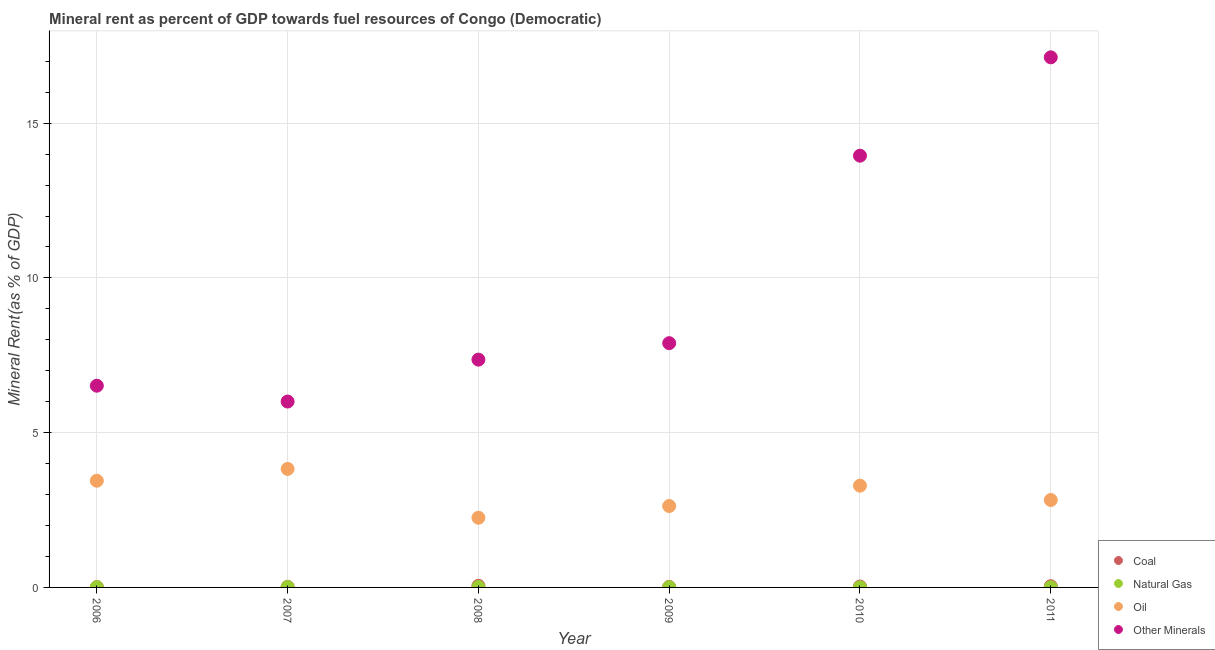How many different coloured dotlines are there?
Give a very brief answer. 4. Is the number of dotlines equal to the number of legend labels?
Keep it short and to the point. Yes. What is the oil rent in 2009?
Your answer should be compact. 2.63. Across all years, what is the maximum  rent of other minerals?
Make the answer very short. 17.13. Across all years, what is the minimum  rent of other minerals?
Provide a short and direct response. 6.01. In which year was the  rent of other minerals maximum?
Provide a succinct answer. 2011. In which year was the oil rent minimum?
Your answer should be compact. 2008. What is the total oil rent in the graph?
Provide a succinct answer. 18.27. What is the difference between the coal rent in 2006 and that in 2007?
Keep it short and to the point. -0.01. What is the difference between the  rent of other minerals in 2011 and the natural gas rent in 2007?
Give a very brief answer. 17.11. What is the average oil rent per year?
Provide a short and direct response. 3.05. In the year 2010, what is the difference between the oil rent and  rent of other minerals?
Ensure brevity in your answer.  -10.66. In how many years, is the natural gas rent greater than 7 %?
Provide a succinct answer. 0. What is the ratio of the natural gas rent in 2006 to that in 2010?
Provide a succinct answer. 1.09. What is the difference between the highest and the second highest coal rent?
Provide a succinct answer. 0.01. What is the difference between the highest and the lowest  rent of other minerals?
Ensure brevity in your answer.  11.12. In how many years, is the oil rent greater than the average oil rent taken over all years?
Offer a very short reply. 3. Is the sum of the natural gas rent in 2007 and 2009 greater than the maximum oil rent across all years?
Your answer should be compact. No. Is it the case that in every year, the sum of the coal rent and natural gas rent is greater than the oil rent?
Ensure brevity in your answer.  No. Is the oil rent strictly less than the  rent of other minerals over the years?
Ensure brevity in your answer.  Yes. How many dotlines are there?
Your answer should be very brief. 4. Are the values on the major ticks of Y-axis written in scientific E-notation?
Your response must be concise. No. Where does the legend appear in the graph?
Offer a very short reply. Bottom right. How are the legend labels stacked?
Make the answer very short. Vertical. What is the title of the graph?
Keep it short and to the point. Mineral rent as percent of GDP towards fuel resources of Congo (Democratic). What is the label or title of the Y-axis?
Ensure brevity in your answer.  Mineral Rent(as % of GDP). What is the Mineral Rent(as % of GDP) in Coal in 2006?
Provide a succinct answer. 0.01. What is the Mineral Rent(as % of GDP) of Natural Gas in 2006?
Provide a succinct answer. 0.01. What is the Mineral Rent(as % of GDP) of Oil in 2006?
Your response must be concise. 3.45. What is the Mineral Rent(as % of GDP) of Other Minerals in 2006?
Keep it short and to the point. 6.52. What is the Mineral Rent(as % of GDP) of Coal in 2007?
Give a very brief answer. 0.02. What is the Mineral Rent(as % of GDP) of Natural Gas in 2007?
Ensure brevity in your answer.  0.01. What is the Mineral Rent(as % of GDP) of Oil in 2007?
Your answer should be very brief. 3.83. What is the Mineral Rent(as % of GDP) of Other Minerals in 2007?
Keep it short and to the point. 6.01. What is the Mineral Rent(as % of GDP) of Coal in 2008?
Your response must be concise. 0.05. What is the Mineral Rent(as % of GDP) in Natural Gas in 2008?
Keep it short and to the point. 0.02. What is the Mineral Rent(as % of GDP) in Oil in 2008?
Your response must be concise. 2.25. What is the Mineral Rent(as % of GDP) in Other Minerals in 2008?
Make the answer very short. 7.36. What is the Mineral Rent(as % of GDP) of Coal in 2009?
Keep it short and to the point. 0.02. What is the Mineral Rent(as % of GDP) in Natural Gas in 2009?
Your answer should be compact. 0.01. What is the Mineral Rent(as % of GDP) of Oil in 2009?
Your answer should be very brief. 2.63. What is the Mineral Rent(as % of GDP) in Other Minerals in 2009?
Offer a terse response. 7.89. What is the Mineral Rent(as % of GDP) in Coal in 2010?
Your answer should be very brief. 0.03. What is the Mineral Rent(as % of GDP) of Natural Gas in 2010?
Provide a succinct answer. 0.01. What is the Mineral Rent(as % of GDP) in Oil in 2010?
Provide a succinct answer. 3.29. What is the Mineral Rent(as % of GDP) of Other Minerals in 2010?
Keep it short and to the point. 13.95. What is the Mineral Rent(as % of GDP) in Coal in 2011?
Provide a short and direct response. 0.04. What is the Mineral Rent(as % of GDP) of Natural Gas in 2011?
Your response must be concise. 0.01. What is the Mineral Rent(as % of GDP) of Oil in 2011?
Ensure brevity in your answer.  2.82. What is the Mineral Rent(as % of GDP) of Other Minerals in 2011?
Your answer should be very brief. 17.13. Across all years, what is the maximum Mineral Rent(as % of GDP) of Coal?
Offer a terse response. 0.05. Across all years, what is the maximum Mineral Rent(as % of GDP) in Natural Gas?
Your answer should be compact. 0.02. Across all years, what is the maximum Mineral Rent(as % of GDP) of Oil?
Give a very brief answer. 3.83. Across all years, what is the maximum Mineral Rent(as % of GDP) in Other Minerals?
Give a very brief answer. 17.13. Across all years, what is the minimum Mineral Rent(as % of GDP) of Coal?
Make the answer very short. 0.01. Across all years, what is the minimum Mineral Rent(as % of GDP) of Natural Gas?
Offer a terse response. 0.01. Across all years, what is the minimum Mineral Rent(as % of GDP) in Oil?
Your response must be concise. 2.25. Across all years, what is the minimum Mineral Rent(as % of GDP) of Other Minerals?
Make the answer very short. 6.01. What is the total Mineral Rent(as % of GDP) in Coal in the graph?
Provide a short and direct response. 0.17. What is the total Mineral Rent(as % of GDP) of Natural Gas in the graph?
Offer a very short reply. 0.05. What is the total Mineral Rent(as % of GDP) of Oil in the graph?
Provide a succinct answer. 18.27. What is the total Mineral Rent(as % of GDP) of Other Minerals in the graph?
Your response must be concise. 58.85. What is the difference between the Mineral Rent(as % of GDP) in Coal in 2006 and that in 2007?
Keep it short and to the point. -0.01. What is the difference between the Mineral Rent(as % of GDP) in Natural Gas in 2006 and that in 2007?
Give a very brief answer. -0.01. What is the difference between the Mineral Rent(as % of GDP) in Oil in 2006 and that in 2007?
Your answer should be very brief. -0.38. What is the difference between the Mineral Rent(as % of GDP) of Other Minerals in 2006 and that in 2007?
Provide a short and direct response. 0.51. What is the difference between the Mineral Rent(as % of GDP) in Coal in 2006 and that in 2008?
Your answer should be very brief. -0.04. What is the difference between the Mineral Rent(as % of GDP) in Natural Gas in 2006 and that in 2008?
Provide a short and direct response. -0.01. What is the difference between the Mineral Rent(as % of GDP) in Oil in 2006 and that in 2008?
Your answer should be compact. 1.2. What is the difference between the Mineral Rent(as % of GDP) in Other Minerals in 2006 and that in 2008?
Offer a very short reply. -0.84. What is the difference between the Mineral Rent(as % of GDP) in Coal in 2006 and that in 2009?
Make the answer very short. -0.01. What is the difference between the Mineral Rent(as % of GDP) of Natural Gas in 2006 and that in 2009?
Your response must be concise. -0. What is the difference between the Mineral Rent(as % of GDP) of Oil in 2006 and that in 2009?
Provide a short and direct response. 0.82. What is the difference between the Mineral Rent(as % of GDP) in Other Minerals in 2006 and that in 2009?
Make the answer very short. -1.37. What is the difference between the Mineral Rent(as % of GDP) in Coal in 2006 and that in 2010?
Your answer should be very brief. -0.02. What is the difference between the Mineral Rent(as % of GDP) of Natural Gas in 2006 and that in 2010?
Ensure brevity in your answer.  0. What is the difference between the Mineral Rent(as % of GDP) in Oil in 2006 and that in 2010?
Your answer should be very brief. 0.16. What is the difference between the Mineral Rent(as % of GDP) in Other Minerals in 2006 and that in 2010?
Give a very brief answer. -7.43. What is the difference between the Mineral Rent(as % of GDP) of Coal in 2006 and that in 2011?
Ensure brevity in your answer.  -0.03. What is the difference between the Mineral Rent(as % of GDP) of Natural Gas in 2006 and that in 2011?
Provide a short and direct response. 0. What is the difference between the Mineral Rent(as % of GDP) in Oil in 2006 and that in 2011?
Give a very brief answer. 0.62. What is the difference between the Mineral Rent(as % of GDP) in Other Minerals in 2006 and that in 2011?
Your answer should be compact. -10.61. What is the difference between the Mineral Rent(as % of GDP) of Coal in 2007 and that in 2008?
Keep it short and to the point. -0.03. What is the difference between the Mineral Rent(as % of GDP) of Natural Gas in 2007 and that in 2008?
Your answer should be very brief. -0. What is the difference between the Mineral Rent(as % of GDP) in Oil in 2007 and that in 2008?
Make the answer very short. 1.58. What is the difference between the Mineral Rent(as % of GDP) of Other Minerals in 2007 and that in 2008?
Provide a succinct answer. -1.35. What is the difference between the Mineral Rent(as % of GDP) of Natural Gas in 2007 and that in 2009?
Offer a very short reply. 0. What is the difference between the Mineral Rent(as % of GDP) of Oil in 2007 and that in 2009?
Keep it short and to the point. 1.2. What is the difference between the Mineral Rent(as % of GDP) in Other Minerals in 2007 and that in 2009?
Offer a terse response. -1.89. What is the difference between the Mineral Rent(as % of GDP) of Coal in 2007 and that in 2010?
Your answer should be compact. -0.01. What is the difference between the Mineral Rent(as % of GDP) of Natural Gas in 2007 and that in 2010?
Your answer should be compact. 0.01. What is the difference between the Mineral Rent(as % of GDP) in Oil in 2007 and that in 2010?
Offer a terse response. 0.54. What is the difference between the Mineral Rent(as % of GDP) of Other Minerals in 2007 and that in 2010?
Keep it short and to the point. -7.94. What is the difference between the Mineral Rent(as % of GDP) of Coal in 2007 and that in 2011?
Provide a short and direct response. -0.02. What is the difference between the Mineral Rent(as % of GDP) of Natural Gas in 2007 and that in 2011?
Your answer should be compact. 0.01. What is the difference between the Mineral Rent(as % of GDP) of Other Minerals in 2007 and that in 2011?
Provide a short and direct response. -11.12. What is the difference between the Mineral Rent(as % of GDP) in Coal in 2008 and that in 2009?
Your answer should be very brief. 0.04. What is the difference between the Mineral Rent(as % of GDP) of Natural Gas in 2008 and that in 2009?
Offer a very short reply. 0.01. What is the difference between the Mineral Rent(as % of GDP) of Oil in 2008 and that in 2009?
Provide a short and direct response. -0.38. What is the difference between the Mineral Rent(as % of GDP) of Other Minerals in 2008 and that in 2009?
Your response must be concise. -0.53. What is the difference between the Mineral Rent(as % of GDP) of Coal in 2008 and that in 2010?
Provide a succinct answer. 0.02. What is the difference between the Mineral Rent(as % of GDP) in Natural Gas in 2008 and that in 2010?
Provide a short and direct response. 0.01. What is the difference between the Mineral Rent(as % of GDP) in Oil in 2008 and that in 2010?
Offer a terse response. -1.04. What is the difference between the Mineral Rent(as % of GDP) in Other Minerals in 2008 and that in 2010?
Your response must be concise. -6.59. What is the difference between the Mineral Rent(as % of GDP) in Coal in 2008 and that in 2011?
Give a very brief answer. 0.01. What is the difference between the Mineral Rent(as % of GDP) of Natural Gas in 2008 and that in 2011?
Your answer should be compact. 0.01. What is the difference between the Mineral Rent(as % of GDP) in Oil in 2008 and that in 2011?
Your answer should be compact. -0.57. What is the difference between the Mineral Rent(as % of GDP) of Other Minerals in 2008 and that in 2011?
Your response must be concise. -9.77. What is the difference between the Mineral Rent(as % of GDP) of Coal in 2009 and that in 2010?
Make the answer very short. -0.01. What is the difference between the Mineral Rent(as % of GDP) in Natural Gas in 2009 and that in 2010?
Make the answer very short. 0. What is the difference between the Mineral Rent(as % of GDP) in Oil in 2009 and that in 2010?
Give a very brief answer. -0.66. What is the difference between the Mineral Rent(as % of GDP) of Other Minerals in 2009 and that in 2010?
Provide a short and direct response. -6.06. What is the difference between the Mineral Rent(as % of GDP) in Coal in 2009 and that in 2011?
Ensure brevity in your answer.  -0.02. What is the difference between the Mineral Rent(as % of GDP) in Natural Gas in 2009 and that in 2011?
Ensure brevity in your answer.  0. What is the difference between the Mineral Rent(as % of GDP) in Oil in 2009 and that in 2011?
Make the answer very short. -0.19. What is the difference between the Mineral Rent(as % of GDP) of Other Minerals in 2009 and that in 2011?
Offer a terse response. -9.24. What is the difference between the Mineral Rent(as % of GDP) in Coal in 2010 and that in 2011?
Your answer should be compact. -0.01. What is the difference between the Mineral Rent(as % of GDP) in Oil in 2010 and that in 2011?
Provide a succinct answer. 0.46. What is the difference between the Mineral Rent(as % of GDP) in Other Minerals in 2010 and that in 2011?
Your answer should be very brief. -3.18. What is the difference between the Mineral Rent(as % of GDP) of Coal in 2006 and the Mineral Rent(as % of GDP) of Natural Gas in 2007?
Your answer should be very brief. -0. What is the difference between the Mineral Rent(as % of GDP) of Coal in 2006 and the Mineral Rent(as % of GDP) of Oil in 2007?
Ensure brevity in your answer.  -3.82. What is the difference between the Mineral Rent(as % of GDP) in Coal in 2006 and the Mineral Rent(as % of GDP) in Other Minerals in 2007?
Give a very brief answer. -6. What is the difference between the Mineral Rent(as % of GDP) in Natural Gas in 2006 and the Mineral Rent(as % of GDP) in Oil in 2007?
Give a very brief answer. -3.82. What is the difference between the Mineral Rent(as % of GDP) of Natural Gas in 2006 and the Mineral Rent(as % of GDP) of Other Minerals in 2007?
Your answer should be compact. -6. What is the difference between the Mineral Rent(as % of GDP) of Oil in 2006 and the Mineral Rent(as % of GDP) of Other Minerals in 2007?
Provide a short and direct response. -2.56. What is the difference between the Mineral Rent(as % of GDP) of Coal in 2006 and the Mineral Rent(as % of GDP) of Natural Gas in 2008?
Ensure brevity in your answer.  -0.01. What is the difference between the Mineral Rent(as % of GDP) in Coal in 2006 and the Mineral Rent(as % of GDP) in Oil in 2008?
Offer a very short reply. -2.24. What is the difference between the Mineral Rent(as % of GDP) in Coal in 2006 and the Mineral Rent(as % of GDP) in Other Minerals in 2008?
Make the answer very short. -7.35. What is the difference between the Mineral Rent(as % of GDP) in Natural Gas in 2006 and the Mineral Rent(as % of GDP) in Oil in 2008?
Your response must be concise. -2.24. What is the difference between the Mineral Rent(as % of GDP) in Natural Gas in 2006 and the Mineral Rent(as % of GDP) in Other Minerals in 2008?
Your answer should be compact. -7.35. What is the difference between the Mineral Rent(as % of GDP) in Oil in 2006 and the Mineral Rent(as % of GDP) in Other Minerals in 2008?
Offer a terse response. -3.91. What is the difference between the Mineral Rent(as % of GDP) in Coal in 2006 and the Mineral Rent(as % of GDP) in Natural Gas in 2009?
Your answer should be compact. 0. What is the difference between the Mineral Rent(as % of GDP) of Coal in 2006 and the Mineral Rent(as % of GDP) of Oil in 2009?
Make the answer very short. -2.62. What is the difference between the Mineral Rent(as % of GDP) in Coal in 2006 and the Mineral Rent(as % of GDP) in Other Minerals in 2009?
Give a very brief answer. -7.88. What is the difference between the Mineral Rent(as % of GDP) in Natural Gas in 2006 and the Mineral Rent(as % of GDP) in Oil in 2009?
Your response must be concise. -2.62. What is the difference between the Mineral Rent(as % of GDP) of Natural Gas in 2006 and the Mineral Rent(as % of GDP) of Other Minerals in 2009?
Your response must be concise. -7.88. What is the difference between the Mineral Rent(as % of GDP) of Oil in 2006 and the Mineral Rent(as % of GDP) of Other Minerals in 2009?
Your answer should be compact. -4.44. What is the difference between the Mineral Rent(as % of GDP) in Coal in 2006 and the Mineral Rent(as % of GDP) in Natural Gas in 2010?
Keep it short and to the point. 0. What is the difference between the Mineral Rent(as % of GDP) in Coal in 2006 and the Mineral Rent(as % of GDP) in Oil in 2010?
Provide a succinct answer. -3.28. What is the difference between the Mineral Rent(as % of GDP) in Coal in 2006 and the Mineral Rent(as % of GDP) in Other Minerals in 2010?
Your response must be concise. -13.94. What is the difference between the Mineral Rent(as % of GDP) of Natural Gas in 2006 and the Mineral Rent(as % of GDP) of Oil in 2010?
Offer a terse response. -3.28. What is the difference between the Mineral Rent(as % of GDP) in Natural Gas in 2006 and the Mineral Rent(as % of GDP) in Other Minerals in 2010?
Your response must be concise. -13.94. What is the difference between the Mineral Rent(as % of GDP) of Oil in 2006 and the Mineral Rent(as % of GDP) of Other Minerals in 2010?
Your answer should be very brief. -10.5. What is the difference between the Mineral Rent(as % of GDP) of Coal in 2006 and the Mineral Rent(as % of GDP) of Natural Gas in 2011?
Make the answer very short. 0. What is the difference between the Mineral Rent(as % of GDP) of Coal in 2006 and the Mineral Rent(as % of GDP) of Oil in 2011?
Give a very brief answer. -2.81. What is the difference between the Mineral Rent(as % of GDP) of Coal in 2006 and the Mineral Rent(as % of GDP) of Other Minerals in 2011?
Ensure brevity in your answer.  -17.12. What is the difference between the Mineral Rent(as % of GDP) in Natural Gas in 2006 and the Mineral Rent(as % of GDP) in Oil in 2011?
Provide a short and direct response. -2.82. What is the difference between the Mineral Rent(as % of GDP) of Natural Gas in 2006 and the Mineral Rent(as % of GDP) of Other Minerals in 2011?
Keep it short and to the point. -17.12. What is the difference between the Mineral Rent(as % of GDP) in Oil in 2006 and the Mineral Rent(as % of GDP) in Other Minerals in 2011?
Ensure brevity in your answer.  -13.68. What is the difference between the Mineral Rent(as % of GDP) of Coal in 2007 and the Mineral Rent(as % of GDP) of Natural Gas in 2008?
Make the answer very short. 0. What is the difference between the Mineral Rent(as % of GDP) of Coal in 2007 and the Mineral Rent(as % of GDP) of Oil in 2008?
Offer a terse response. -2.23. What is the difference between the Mineral Rent(as % of GDP) of Coal in 2007 and the Mineral Rent(as % of GDP) of Other Minerals in 2008?
Give a very brief answer. -7.34. What is the difference between the Mineral Rent(as % of GDP) in Natural Gas in 2007 and the Mineral Rent(as % of GDP) in Oil in 2008?
Provide a short and direct response. -2.24. What is the difference between the Mineral Rent(as % of GDP) in Natural Gas in 2007 and the Mineral Rent(as % of GDP) in Other Minerals in 2008?
Ensure brevity in your answer.  -7.35. What is the difference between the Mineral Rent(as % of GDP) of Oil in 2007 and the Mineral Rent(as % of GDP) of Other Minerals in 2008?
Offer a terse response. -3.53. What is the difference between the Mineral Rent(as % of GDP) in Coal in 2007 and the Mineral Rent(as % of GDP) in Natural Gas in 2009?
Ensure brevity in your answer.  0.01. What is the difference between the Mineral Rent(as % of GDP) of Coal in 2007 and the Mineral Rent(as % of GDP) of Oil in 2009?
Provide a succinct answer. -2.61. What is the difference between the Mineral Rent(as % of GDP) in Coal in 2007 and the Mineral Rent(as % of GDP) in Other Minerals in 2009?
Keep it short and to the point. -7.87. What is the difference between the Mineral Rent(as % of GDP) in Natural Gas in 2007 and the Mineral Rent(as % of GDP) in Oil in 2009?
Your response must be concise. -2.62. What is the difference between the Mineral Rent(as % of GDP) of Natural Gas in 2007 and the Mineral Rent(as % of GDP) of Other Minerals in 2009?
Provide a short and direct response. -7.88. What is the difference between the Mineral Rent(as % of GDP) of Oil in 2007 and the Mineral Rent(as % of GDP) of Other Minerals in 2009?
Offer a terse response. -4.06. What is the difference between the Mineral Rent(as % of GDP) of Coal in 2007 and the Mineral Rent(as % of GDP) of Natural Gas in 2010?
Give a very brief answer. 0.01. What is the difference between the Mineral Rent(as % of GDP) in Coal in 2007 and the Mineral Rent(as % of GDP) in Oil in 2010?
Ensure brevity in your answer.  -3.27. What is the difference between the Mineral Rent(as % of GDP) in Coal in 2007 and the Mineral Rent(as % of GDP) in Other Minerals in 2010?
Provide a succinct answer. -13.93. What is the difference between the Mineral Rent(as % of GDP) of Natural Gas in 2007 and the Mineral Rent(as % of GDP) of Oil in 2010?
Offer a terse response. -3.28. What is the difference between the Mineral Rent(as % of GDP) of Natural Gas in 2007 and the Mineral Rent(as % of GDP) of Other Minerals in 2010?
Provide a succinct answer. -13.94. What is the difference between the Mineral Rent(as % of GDP) in Oil in 2007 and the Mineral Rent(as % of GDP) in Other Minerals in 2010?
Offer a very short reply. -10.12. What is the difference between the Mineral Rent(as % of GDP) of Coal in 2007 and the Mineral Rent(as % of GDP) of Natural Gas in 2011?
Your answer should be compact. 0.01. What is the difference between the Mineral Rent(as % of GDP) in Coal in 2007 and the Mineral Rent(as % of GDP) in Oil in 2011?
Make the answer very short. -2.81. What is the difference between the Mineral Rent(as % of GDP) of Coal in 2007 and the Mineral Rent(as % of GDP) of Other Minerals in 2011?
Your response must be concise. -17.11. What is the difference between the Mineral Rent(as % of GDP) in Natural Gas in 2007 and the Mineral Rent(as % of GDP) in Oil in 2011?
Keep it short and to the point. -2.81. What is the difference between the Mineral Rent(as % of GDP) in Natural Gas in 2007 and the Mineral Rent(as % of GDP) in Other Minerals in 2011?
Offer a very short reply. -17.11. What is the difference between the Mineral Rent(as % of GDP) of Oil in 2007 and the Mineral Rent(as % of GDP) of Other Minerals in 2011?
Provide a succinct answer. -13.3. What is the difference between the Mineral Rent(as % of GDP) in Coal in 2008 and the Mineral Rent(as % of GDP) in Natural Gas in 2009?
Give a very brief answer. 0.04. What is the difference between the Mineral Rent(as % of GDP) in Coal in 2008 and the Mineral Rent(as % of GDP) in Oil in 2009?
Offer a very short reply. -2.58. What is the difference between the Mineral Rent(as % of GDP) of Coal in 2008 and the Mineral Rent(as % of GDP) of Other Minerals in 2009?
Provide a succinct answer. -7.84. What is the difference between the Mineral Rent(as % of GDP) in Natural Gas in 2008 and the Mineral Rent(as % of GDP) in Oil in 2009?
Keep it short and to the point. -2.62. What is the difference between the Mineral Rent(as % of GDP) of Natural Gas in 2008 and the Mineral Rent(as % of GDP) of Other Minerals in 2009?
Keep it short and to the point. -7.88. What is the difference between the Mineral Rent(as % of GDP) of Oil in 2008 and the Mineral Rent(as % of GDP) of Other Minerals in 2009?
Give a very brief answer. -5.64. What is the difference between the Mineral Rent(as % of GDP) of Coal in 2008 and the Mineral Rent(as % of GDP) of Natural Gas in 2010?
Provide a succinct answer. 0.05. What is the difference between the Mineral Rent(as % of GDP) of Coal in 2008 and the Mineral Rent(as % of GDP) of Oil in 2010?
Ensure brevity in your answer.  -3.24. What is the difference between the Mineral Rent(as % of GDP) of Coal in 2008 and the Mineral Rent(as % of GDP) of Other Minerals in 2010?
Give a very brief answer. -13.9. What is the difference between the Mineral Rent(as % of GDP) of Natural Gas in 2008 and the Mineral Rent(as % of GDP) of Oil in 2010?
Offer a terse response. -3.27. What is the difference between the Mineral Rent(as % of GDP) of Natural Gas in 2008 and the Mineral Rent(as % of GDP) of Other Minerals in 2010?
Provide a succinct answer. -13.93. What is the difference between the Mineral Rent(as % of GDP) of Oil in 2008 and the Mineral Rent(as % of GDP) of Other Minerals in 2010?
Ensure brevity in your answer.  -11.7. What is the difference between the Mineral Rent(as % of GDP) of Coal in 2008 and the Mineral Rent(as % of GDP) of Natural Gas in 2011?
Offer a very short reply. 0.05. What is the difference between the Mineral Rent(as % of GDP) in Coal in 2008 and the Mineral Rent(as % of GDP) in Oil in 2011?
Offer a terse response. -2.77. What is the difference between the Mineral Rent(as % of GDP) of Coal in 2008 and the Mineral Rent(as % of GDP) of Other Minerals in 2011?
Give a very brief answer. -17.07. What is the difference between the Mineral Rent(as % of GDP) of Natural Gas in 2008 and the Mineral Rent(as % of GDP) of Oil in 2011?
Offer a very short reply. -2.81. What is the difference between the Mineral Rent(as % of GDP) in Natural Gas in 2008 and the Mineral Rent(as % of GDP) in Other Minerals in 2011?
Your answer should be compact. -17.11. What is the difference between the Mineral Rent(as % of GDP) in Oil in 2008 and the Mineral Rent(as % of GDP) in Other Minerals in 2011?
Provide a succinct answer. -14.88. What is the difference between the Mineral Rent(as % of GDP) of Coal in 2009 and the Mineral Rent(as % of GDP) of Natural Gas in 2010?
Offer a terse response. 0.01. What is the difference between the Mineral Rent(as % of GDP) of Coal in 2009 and the Mineral Rent(as % of GDP) of Oil in 2010?
Provide a short and direct response. -3.27. What is the difference between the Mineral Rent(as % of GDP) in Coal in 2009 and the Mineral Rent(as % of GDP) in Other Minerals in 2010?
Your answer should be very brief. -13.93. What is the difference between the Mineral Rent(as % of GDP) in Natural Gas in 2009 and the Mineral Rent(as % of GDP) in Oil in 2010?
Keep it short and to the point. -3.28. What is the difference between the Mineral Rent(as % of GDP) in Natural Gas in 2009 and the Mineral Rent(as % of GDP) in Other Minerals in 2010?
Your response must be concise. -13.94. What is the difference between the Mineral Rent(as % of GDP) of Oil in 2009 and the Mineral Rent(as % of GDP) of Other Minerals in 2010?
Provide a short and direct response. -11.32. What is the difference between the Mineral Rent(as % of GDP) in Coal in 2009 and the Mineral Rent(as % of GDP) in Natural Gas in 2011?
Your answer should be compact. 0.01. What is the difference between the Mineral Rent(as % of GDP) in Coal in 2009 and the Mineral Rent(as % of GDP) in Oil in 2011?
Offer a very short reply. -2.81. What is the difference between the Mineral Rent(as % of GDP) of Coal in 2009 and the Mineral Rent(as % of GDP) of Other Minerals in 2011?
Keep it short and to the point. -17.11. What is the difference between the Mineral Rent(as % of GDP) of Natural Gas in 2009 and the Mineral Rent(as % of GDP) of Oil in 2011?
Give a very brief answer. -2.82. What is the difference between the Mineral Rent(as % of GDP) in Natural Gas in 2009 and the Mineral Rent(as % of GDP) in Other Minerals in 2011?
Provide a succinct answer. -17.12. What is the difference between the Mineral Rent(as % of GDP) in Oil in 2009 and the Mineral Rent(as % of GDP) in Other Minerals in 2011?
Offer a very short reply. -14.5. What is the difference between the Mineral Rent(as % of GDP) in Coal in 2010 and the Mineral Rent(as % of GDP) in Natural Gas in 2011?
Keep it short and to the point. 0.02. What is the difference between the Mineral Rent(as % of GDP) of Coal in 2010 and the Mineral Rent(as % of GDP) of Oil in 2011?
Give a very brief answer. -2.79. What is the difference between the Mineral Rent(as % of GDP) of Coal in 2010 and the Mineral Rent(as % of GDP) of Other Minerals in 2011?
Keep it short and to the point. -17.1. What is the difference between the Mineral Rent(as % of GDP) of Natural Gas in 2010 and the Mineral Rent(as % of GDP) of Oil in 2011?
Give a very brief answer. -2.82. What is the difference between the Mineral Rent(as % of GDP) in Natural Gas in 2010 and the Mineral Rent(as % of GDP) in Other Minerals in 2011?
Ensure brevity in your answer.  -17.12. What is the difference between the Mineral Rent(as % of GDP) in Oil in 2010 and the Mineral Rent(as % of GDP) in Other Minerals in 2011?
Your answer should be compact. -13.84. What is the average Mineral Rent(as % of GDP) in Coal per year?
Give a very brief answer. 0.03. What is the average Mineral Rent(as % of GDP) of Natural Gas per year?
Offer a very short reply. 0.01. What is the average Mineral Rent(as % of GDP) of Oil per year?
Make the answer very short. 3.04. What is the average Mineral Rent(as % of GDP) in Other Minerals per year?
Your answer should be compact. 9.81. In the year 2006, what is the difference between the Mineral Rent(as % of GDP) of Coal and Mineral Rent(as % of GDP) of Natural Gas?
Your response must be concise. 0. In the year 2006, what is the difference between the Mineral Rent(as % of GDP) of Coal and Mineral Rent(as % of GDP) of Oil?
Your response must be concise. -3.44. In the year 2006, what is the difference between the Mineral Rent(as % of GDP) in Coal and Mineral Rent(as % of GDP) in Other Minerals?
Ensure brevity in your answer.  -6.51. In the year 2006, what is the difference between the Mineral Rent(as % of GDP) in Natural Gas and Mineral Rent(as % of GDP) in Oil?
Your response must be concise. -3.44. In the year 2006, what is the difference between the Mineral Rent(as % of GDP) of Natural Gas and Mineral Rent(as % of GDP) of Other Minerals?
Provide a short and direct response. -6.51. In the year 2006, what is the difference between the Mineral Rent(as % of GDP) of Oil and Mineral Rent(as % of GDP) of Other Minerals?
Keep it short and to the point. -3.07. In the year 2007, what is the difference between the Mineral Rent(as % of GDP) in Coal and Mineral Rent(as % of GDP) in Natural Gas?
Give a very brief answer. 0.01. In the year 2007, what is the difference between the Mineral Rent(as % of GDP) of Coal and Mineral Rent(as % of GDP) of Oil?
Ensure brevity in your answer.  -3.81. In the year 2007, what is the difference between the Mineral Rent(as % of GDP) in Coal and Mineral Rent(as % of GDP) in Other Minerals?
Provide a short and direct response. -5.99. In the year 2007, what is the difference between the Mineral Rent(as % of GDP) in Natural Gas and Mineral Rent(as % of GDP) in Oil?
Offer a very short reply. -3.82. In the year 2007, what is the difference between the Mineral Rent(as % of GDP) in Natural Gas and Mineral Rent(as % of GDP) in Other Minerals?
Give a very brief answer. -5.99. In the year 2007, what is the difference between the Mineral Rent(as % of GDP) in Oil and Mineral Rent(as % of GDP) in Other Minerals?
Make the answer very short. -2.18. In the year 2008, what is the difference between the Mineral Rent(as % of GDP) in Coal and Mineral Rent(as % of GDP) in Natural Gas?
Your response must be concise. 0.04. In the year 2008, what is the difference between the Mineral Rent(as % of GDP) in Coal and Mineral Rent(as % of GDP) in Oil?
Your response must be concise. -2.2. In the year 2008, what is the difference between the Mineral Rent(as % of GDP) of Coal and Mineral Rent(as % of GDP) of Other Minerals?
Provide a short and direct response. -7.31. In the year 2008, what is the difference between the Mineral Rent(as % of GDP) in Natural Gas and Mineral Rent(as % of GDP) in Oil?
Your answer should be very brief. -2.24. In the year 2008, what is the difference between the Mineral Rent(as % of GDP) in Natural Gas and Mineral Rent(as % of GDP) in Other Minerals?
Keep it short and to the point. -7.34. In the year 2008, what is the difference between the Mineral Rent(as % of GDP) in Oil and Mineral Rent(as % of GDP) in Other Minerals?
Your response must be concise. -5.11. In the year 2009, what is the difference between the Mineral Rent(as % of GDP) in Coal and Mineral Rent(as % of GDP) in Natural Gas?
Offer a terse response. 0.01. In the year 2009, what is the difference between the Mineral Rent(as % of GDP) of Coal and Mineral Rent(as % of GDP) of Oil?
Offer a very short reply. -2.61. In the year 2009, what is the difference between the Mineral Rent(as % of GDP) in Coal and Mineral Rent(as % of GDP) in Other Minerals?
Make the answer very short. -7.87. In the year 2009, what is the difference between the Mineral Rent(as % of GDP) in Natural Gas and Mineral Rent(as % of GDP) in Oil?
Make the answer very short. -2.62. In the year 2009, what is the difference between the Mineral Rent(as % of GDP) of Natural Gas and Mineral Rent(as % of GDP) of Other Minerals?
Offer a very short reply. -7.88. In the year 2009, what is the difference between the Mineral Rent(as % of GDP) of Oil and Mineral Rent(as % of GDP) of Other Minerals?
Keep it short and to the point. -5.26. In the year 2010, what is the difference between the Mineral Rent(as % of GDP) in Coal and Mineral Rent(as % of GDP) in Natural Gas?
Your answer should be very brief. 0.02. In the year 2010, what is the difference between the Mineral Rent(as % of GDP) in Coal and Mineral Rent(as % of GDP) in Oil?
Offer a very short reply. -3.26. In the year 2010, what is the difference between the Mineral Rent(as % of GDP) of Coal and Mineral Rent(as % of GDP) of Other Minerals?
Offer a terse response. -13.92. In the year 2010, what is the difference between the Mineral Rent(as % of GDP) of Natural Gas and Mineral Rent(as % of GDP) of Oil?
Offer a very short reply. -3.28. In the year 2010, what is the difference between the Mineral Rent(as % of GDP) in Natural Gas and Mineral Rent(as % of GDP) in Other Minerals?
Provide a short and direct response. -13.94. In the year 2010, what is the difference between the Mineral Rent(as % of GDP) in Oil and Mineral Rent(as % of GDP) in Other Minerals?
Give a very brief answer. -10.66. In the year 2011, what is the difference between the Mineral Rent(as % of GDP) in Coal and Mineral Rent(as % of GDP) in Natural Gas?
Give a very brief answer. 0.03. In the year 2011, what is the difference between the Mineral Rent(as % of GDP) in Coal and Mineral Rent(as % of GDP) in Oil?
Make the answer very short. -2.78. In the year 2011, what is the difference between the Mineral Rent(as % of GDP) in Coal and Mineral Rent(as % of GDP) in Other Minerals?
Provide a succinct answer. -17.09. In the year 2011, what is the difference between the Mineral Rent(as % of GDP) of Natural Gas and Mineral Rent(as % of GDP) of Oil?
Your response must be concise. -2.82. In the year 2011, what is the difference between the Mineral Rent(as % of GDP) of Natural Gas and Mineral Rent(as % of GDP) of Other Minerals?
Make the answer very short. -17.12. In the year 2011, what is the difference between the Mineral Rent(as % of GDP) of Oil and Mineral Rent(as % of GDP) of Other Minerals?
Provide a succinct answer. -14.3. What is the ratio of the Mineral Rent(as % of GDP) of Coal in 2006 to that in 2007?
Provide a short and direct response. 0.58. What is the ratio of the Mineral Rent(as % of GDP) of Natural Gas in 2006 to that in 2007?
Give a very brief answer. 0.55. What is the ratio of the Mineral Rent(as % of GDP) in Oil in 2006 to that in 2007?
Make the answer very short. 0.9. What is the ratio of the Mineral Rent(as % of GDP) in Other Minerals in 2006 to that in 2007?
Provide a succinct answer. 1.09. What is the ratio of the Mineral Rent(as % of GDP) of Coal in 2006 to that in 2008?
Provide a short and direct response. 0.19. What is the ratio of the Mineral Rent(as % of GDP) of Natural Gas in 2006 to that in 2008?
Provide a short and direct response. 0.44. What is the ratio of the Mineral Rent(as % of GDP) of Oil in 2006 to that in 2008?
Give a very brief answer. 1.53. What is the ratio of the Mineral Rent(as % of GDP) in Other Minerals in 2006 to that in 2008?
Offer a very short reply. 0.89. What is the ratio of the Mineral Rent(as % of GDP) in Coal in 2006 to that in 2009?
Provide a short and direct response. 0.59. What is the ratio of the Mineral Rent(as % of GDP) in Natural Gas in 2006 to that in 2009?
Provide a succinct answer. 0.91. What is the ratio of the Mineral Rent(as % of GDP) in Oil in 2006 to that in 2009?
Ensure brevity in your answer.  1.31. What is the ratio of the Mineral Rent(as % of GDP) in Other Minerals in 2006 to that in 2009?
Your answer should be very brief. 0.83. What is the ratio of the Mineral Rent(as % of GDP) in Coal in 2006 to that in 2010?
Provide a succinct answer. 0.33. What is the ratio of the Mineral Rent(as % of GDP) in Natural Gas in 2006 to that in 2010?
Your response must be concise. 1.09. What is the ratio of the Mineral Rent(as % of GDP) of Oil in 2006 to that in 2010?
Make the answer very short. 1.05. What is the ratio of the Mineral Rent(as % of GDP) in Other Minerals in 2006 to that in 2010?
Your response must be concise. 0.47. What is the ratio of the Mineral Rent(as % of GDP) in Coal in 2006 to that in 2011?
Your answer should be compact. 0.25. What is the ratio of the Mineral Rent(as % of GDP) in Natural Gas in 2006 to that in 2011?
Give a very brief answer. 1.14. What is the ratio of the Mineral Rent(as % of GDP) of Oil in 2006 to that in 2011?
Your answer should be compact. 1.22. What is the ratio of the Mineral Rent(as % of GDP) of Other Minerals in 2006 to that in 2011?
Make the answer very short. 0.38. What is the ratio of the Mineral Rent(as % of GDP) of Coal in 2007 to that in 2008?
Give a very brief answer. 0.33. What is the ratio of the Mineral Rent(as % of GDP) of Natural Gas in 2007 to that in 2008?
Offer a very short reply. 0.8. What is the ratio of the Mineral Rent(as % of GDP) in Oil in 2007 to that in 2008?
Provide a short and direct response. 1.7. What is the ratio of the Mineral Rent(as % of GDP) in Other Minerals in 2007 to that in 2008?
Ensure brevity in your answer.  0.82. What is the ratio of the Mineral Rent(as % of GDP) of Coal in 2007 to that in 2009?
Offer a terse response. 1.01. What is the ratio of the Mineral Rent(as % of GDP) in Natural Gas in 2007 to that in 2009?
Give a very brief answer. 1.65. What is the ratio of the Mineral Rent(as % of GDP) of Oil in 2007 to that in 2009?
Your answer should be very brief. 1.46. What is the ratio of the Mineral Rent(as % of GDP) of Other Minerals in 2007 to that in 2009?
Provide a succinct answer. 0.76. What is the ratio of the Mineral Rent(as % of GDP) in Coal in 2007 to that in 2010?
Give a very brief answer. 0.57. What is the ratio of the Mineral Rent(as % of GDP) in Natural Gas in 2007 to that in 2010?
Offer a terse response. 1.97. What is the ratio of the Mineral Rent(as % of GDP) of Oil in 2007 to that in 2010?
Provide a succinct answer. 1.16. What is the ratio of the Mineral Rent(as % of GDP) of Other Minerals in 2007 to that in 2010?
Keep it short and to the point. 0.43. What is the ratio of the Mineral Rent(as % of GDP) of Coal in 2007 to that in 2011?
Ensure brevity in your answer.  0.43. What is the ratio of the Mineral Rent(as % of GDP) in Natural Gas in 2007 to that in 2011?
Ensure brevity in your answer.  2.06. What is the ratio of the Mineral Rent(as % of GDP) in Oil in 2007 to that in 2011?
Provide a succinct answer. 1.36. What is the ratio of the Mineral Rent(as % of GDP) in Other Minerals in 2007 to that in 2011?
Your answer should be very brief. 0.35. What is the ratio of the Mineral Rent(as % of GDP) in Coal in 2008 to that in 2009?
Provide a succinct answer. 3.05. What is the ratio of the Mineral Rent(as % of GDP) of Natural Gas in 2008 to that in 2009?
Give a very brief answer. 2.06. What is the ratio of the Mineral Rent(as % of GDP) of Oil in 2008 to that in 2009?
Provide a succinct answer. 0.86. What is the ratio of the Mineral Rent(as % of GDP) in Other Minerals in 2008 to that in 2009?
Your answer should be compact. 0.93. What is the ratio of the Mineral Rent(as % of GDP) of Coal in 2008 to that in 2010?
Offer a terse response. 1.71. What is the ratio of the Mineral Rent(as % of GDP) in Natural Gas in 2008 to that in 2010?
Your answer should be very brief. 2.46. What is the ratio of the Mineral Rent(as % of GDP) in Oil in 2008 to that in 2010?
Give a very brief answer. 0.68. What is the ratio of the Mineral Rent(as % of GDP) in Other Minerals in 2008 to that in 2010?
Provide a short and direct response. 0.53. What is the ratio of the Mineral Rent(as % of GDP) of Coal in 2008 to that in 2011?
Offer a terse response. 1.29. What is the ratio of the Mineral Rent(as % of GDP) in Natural Gas in 2008 to that in 2011?
Your answer should be very brief. 2.58. What is the ratio of the Mineral Rent(as % of GDP) in Oil in 2008 to that in 2011?
Offer a very short reply. 0.8. What is the ratio of the Mineral Rent(as % of GDP) in Other Minerals in 2008 to that in 2011?
Provide a succinct answer. 0.43. What is the ratio of the Mineral Rent(as % of GDP) of Coal in 2009 to that in 2010?
Ensure brevity in your answer.  0.56. What is the ratio of the Mineral Rent(as % of GDP) of Natural Gas in 2009 to that in 2010?
Ensure brevity in your answer.  1.2. What is the ratio of the Mineral Rent(as % of GDP) of Oil in 2009 to that in 2010?
Keep it short and to the point. 0.8. What is the ratio of the Mineral Rent(as % of GDP) in Other Minerals in 2009 to that in 2010?
Your answer should be very brief. 0.57. What is the ratio of the Mineral Rent(as % of GDP) in Coal in 2009 to that in 2011?
Your response must be concise. 0.42. What is the ratio of the Mineral Rent(as % of GDP) of Natural Gas in 2009 to that in 2011?
Offer a terse response. 1.25. What is the ratio of the Mineral Rent(as % of GDP) in Oil in 2009 to that in 2011?
Make the answer very short. 0.93. What is the ratio of the Mineral Rent(as % of GDP) of Other Minerals in 2009 to that in 2011?
Ensure brevity in your answer.  0.46. What is the ratio of the Mineral Rent(as % of GDP) of Coal in 2010 to that in 2011?
Offer a very short reply. 0.76. What is the ratio of the Mineral Rent(as % of GDP) in Natural Gas in 2010 to that in 2011?
Your answer should be very brief. 1.05. What is the ratio of the Mineral Rent(as % of GDP) in Oil in 2010 to that in 2011?
Ensure brevity in your answer.  1.16. What is the ratio of the Mineral Rent(as % of GDP) of Other Minerals in 2010 to that in 2011?
Keep it short and to the point. 0.81. What is the difference between the highest and the second highest Mineral Rent(as % of GDP) of Coal?
Your answer should be compact. 0.01. What is the difference between the highest and the second highest Mineral Rent(as % of GDP) in Natural Gas?
Provide a succinct answer. 0. What is the difference between the highest and the second highest Mineral Rent(as % of GDP) of Oil?
Keep it short and to the point. 0.38. What is the difference between the highest and the second highest Mineral Rent(as % of GDP) of Other Minerals?
Provide a succinct answer. 3.18. What is the difference between the highest and the lowest Mineral Rent(as % of GDP) of Coal?
Your answer should be compact. 0.04. What is the difference between the highest and the lowest Mineral Rent(as % of GDP) in Natural Gas?
Provide a succinct answer. 0.01. What is the difference between the highest and the lowest Mineral Rent(as % of GDP) of Oil?
Provide a succinct answer. 1.58. What is the difference between the highest and the lowest Mineral Rent(as % of GDP) in Other Minerals?
Ensure brevity in your answer.  11.12. 